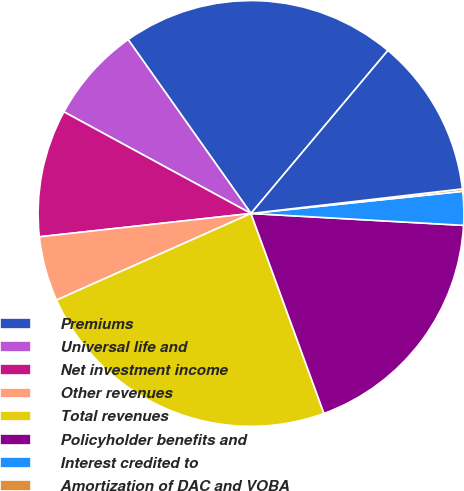Convert chart to OTSL. <chart><loc_0><loc_0><loc_500><loc_500><pie_chart><fcel>Premiums<fcel>Universal life and<fcel>Net investment income<fcel>Other revenues<fcel>Total revenues<fcel>Policyholder benefits and<fcel>Interest credited to<fcel>Amortization of DAC and VOBA<fcel>Other expenses<nl><fcel>20.91%<fcel>7.29%<fcel>9.67%<fcel>4.92%<fcel>23.9%<fcel>18.54%<fcel>2.55%<fcel>0.18%<fcel>12.04%<nl></chart> 